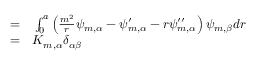<formula> <loc_0><loc_0><loc_500><loc_500>\begin{array} { r l } { = } & \int _ { 0 } ^ { a } \left ( \frac { m ^ { 2 } } { r } \psi _ { m , \alpha } - \psi _ { m , \alpha } ^ { \prime } - r \psi _ { m , \alpha } ^ { \prime \prime } \right ) \psi _ { m , \beta } d r } \\ { = } & K _ { m , \alpha } \delta _ { \alpha \beta } } \end{array}</formula> 